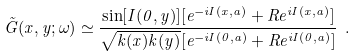<formula> <loc_0><loc_0><loc_500><loc_500>\tilde { G } ( x , y ; \omega ) \simeq \frac { \sin [ I ( 0 , y ) ] [ e ^ { - i I ( x , a ) } + R e ^ { i I ( x , a ) } ] } { \sqrt { k ( x ) k ( y ) } [ e ^ { - i I ( 0 , a ) } + R e ^ { i I ( 0 , a ) } ] } \ .</formula> 